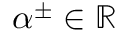Convert formula to latex. <formula><loc_0><loc_0><loc_500><loc_500>\alpha ^ { \pm } \in \mathbb { R }</formula> 